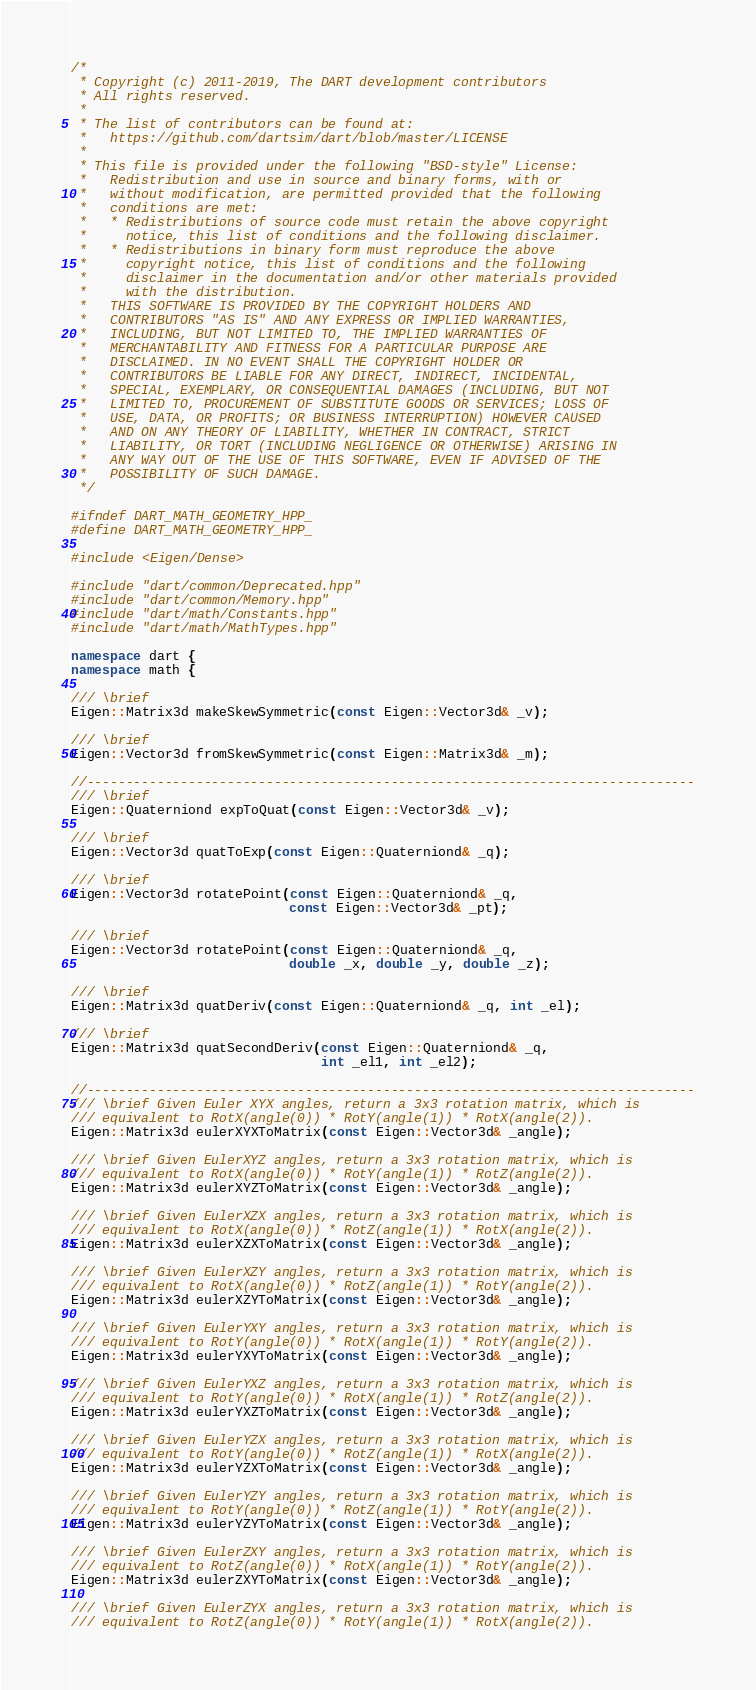<code> <loc_0><loc_0><loc_500><loc_500><_C++_>/*
 * Copyright (c) 2011-2019, The DART development contributors
 * All rights reserved.
 *
 * The list of contributors can be found at:
 *   https://github.com/dartsim/dart/blob/master/LICENSE
 *
 * This file is provided under the following "BSD-style" License:
 *   Redistribution and use in source and binary forms, with or
 *   without modification, are permitted provided that the following
 *   conditions are met:
 *   * Redistributions of source code must retain the above copyright
 *     notice, this list of conditions and the following disclaimer.
 *   * Redistributions in binary form must reproduce the above
 *     copyright notice, this list of conditions and the following
 *     disclaimer in the documentation and/or other materials provided
 *     with the distribution.
 *   THIS SOFTWARE IS PROVIDED BY THE COPYRIGHT HOLDERS AND
 *   CONTRIBUTORS "AS IS" AND ANY EXPRESS OR IMPLIED WARRANTIES,
 *   INCLUDING, BUT NOT LIMITED TO, THE IMPLIED WARRANTIES OF
 *   MERCHANTABILITY AND FITNESS FOR A PARTICULAR PURPOSE ARE
 *   DISCLAIMED. IN NO EVENT SHALL THE COPYRIGHT HOLDER OR
 *   CONTRIBUTORS BE LIABLE FOR ANY DIRECT, INDIRECT, INCIDENTAL,
 *   SPECIAL, EXEMPLARY, OR CONSEQUENTIAL DAMAGES (INCLUDING, BUT NOT
 *   LIMITED TO, PROCUREMENT OF SUBSTITUTE GOODS OR SERVICES; LOSS OF
 *   USE, DATA, OR PROFITS; OR BUSINESS INTERRUPTION) HOWEVER CAUSED
 *   AND ON ANY THEORY OF LIABILITY, WHETHER IN CONTRACT, STRICT
 *   LIABILITY, OR TORT (INCLUDING NEGLIGENCE OR OTHERWISE) ARISING IN
 *   ANY WAY OUT OF THE USE OF THIS SOFTWARE, EVEN IF ADVISED OF THE
 *   POSSIBILITY OF SUCH DAMAGE.
 */

#ifndef DART_MATH_GEOMETRY_HPP_
#define DART_MATH_GEOMETRY_HPP_

#include <Eigen/Dense>

#include "dart/common/Deprecated.hpp"
#include "dart/common/Memory.hpp"
#include "dart/math/Constants.hpp"
#include "dart/math/MathTypes.hpp"

namespace dart {
namespace math {

/// \brief
Eigen::Matrix3d makeSkewSymmetric(const Eigen::Vector3d& _v);

/// \brief
Eigen::Vector3d fromSkewSymmetric(const Eigen::Matrix3d& _m);

//------------------------------------------------------------------------------
/// \brief
Eigen::Quaterniond expToQuat(const Eigen::Vector3d& _v);

/// \brief
Eigen::Vector3d quatToExp(const Eigen::Quaterniond& _q);

/// \brief
Eigen::Vector3d rotatePoint(const Eigen::Quaterniond& _q,
                            const Eigen::Vector3d& _pt);

/// \brief
Eigen::Vector3d rotatePoint(const Eigen::Quaterniond& _q,
                            double _x, double _y, double _z);

/// \brief
Eigen::Matrix3d quatDeriv(const Eigen::Quaterniond& _q, int _el);

/// \brief
Eigen::Matrix3d quatSecondDeriv(const Eigen::Quaterniond& _q,
                                int _el1, int _el2);

//------------------------------------------------------------------------------
/// \brief Given Euler XYX angles, return a 3x3 rotation matrix, which is
/// equivalent to RotX(angle(0)) * RotY(angle(1)) * RotX(angle(2)).
Eigen::Matrix3d eulerXYXToMatrix(const Eigen::Vector3d& _angle);

/// \brief Given EulerXYZ angles, return a 3x3 rotation matrix, which is
/// equivalent to RotX(angle(0)) * RotY(angle(1)) * RotZ(angle(2)).
Eigen::Matrix3d eulerXYZToMatrix(const Eigen::Vector3d& _angle);

/// \brief Given EulerXZX angles, return a 3x3 rotation matrix, which is
/// equivalent to RotX(angle(0)) * RotZ(angle(1)) * RotX(angle(2)).
Eigen::Matrix3d eulerXZXToMatrix(const Eigen::Vector3d& _angle);

/// \brief Given EulerXZY angles, return a 3x3 rotation matrix, which is
/// equivalent to RotX(angle(0)) * RotZ(angle(1)) * RotY(angle(2)).
Eigen::Matrix3d eulerXZYToMatrix(const Eigen::Vector3d& _angle);

/// \brief Given EulerYXY angles, return a 3x3 rotation matrix, which is
/// equivalent to RotY(angle(0)) * RotX(angle(1)) * RotY(angle(2)).
Eigen::Matrix3d eulerYXYToMatrix(const Eigen::Vector3d& _angle);

/// \brief Given EulerYXZ angles, return a 3x3 rotation matrix, which is
/// equivalent to RotY(angle(0)) * RotX(angle(1)) * RotZ(angle(2)).
Eigen::Matrix3d eulerYXZToMatrix(const Eigen::Vector3d& _angle);

/// \brief Given EulerYZX angles, return a 3x3 rotation matrix, which is
/// equivalent to RotY(angle(0)) * RotZ(angle(1)) * RotX(angle(2)).
Eigen::Matrix3d eulerYZXToMatrix(const Eigen::Vector3d& _angle);

/// \brief Given EulerYZY angles, return a 3x3 rotation matrix, which is
/// equivalent to RotY(angle(0)) * RotZ(angle(1)) * RotY(angle(2)).
Eigen::Matrix3d eulerYZYToMatrix(const Eigen::Vector3d& _angle);

/// \brief Given EulerZXY angles, return a 3x3 rotation matrix, which is
/// equivalent to RotZ(angle(0)) * RotX(angle(1)) * RotY(angle(2)).
Eigen::Matrix3d eulerZXYToMatrix(const Eigen::Vector3d& _angle);

/// \brief Given EulerZYX angles, return a 3x3 rotation matrix, which is
/// equivalent to RotZ(angle(0)) * RotY(angle(1)) * RotX(angle(2)).</code> 